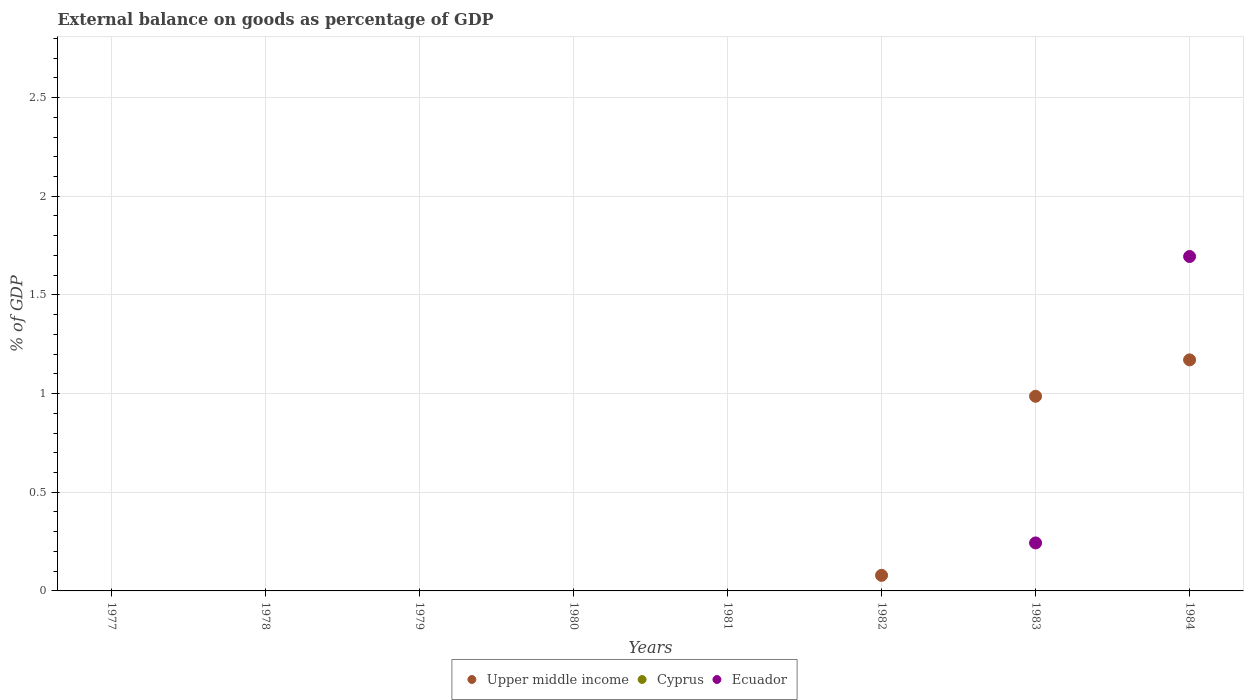Is the number of dotlines equal to the number of legend labels?
Make the answer very short. No. Across all years, what is the maximum external balance on goods as percentage of GDP in Ecuador?
Offer a terse response. 1.69. Across all years, what is the minimum external balance on goods as percentage of GDP in Upper middle income?
Make the answer very short. 0. What is the total external balance on goods as percentage of GDP in Ecuador in the graph?
Provide a short and direct response. 1.94. What is the difference between the external balance on goods as percentage of GDP in Cyprus in 1978 and the external balance on goods as percentage of GDP in Upper middle income in 1980?
Provide a short and direct response. 0. What is the average external balance on goods as percentage of GDP in Ecuador per year?
Your answer should be compact. 0.24. What is the difference between the highest and the second highest external balance on goods as percentage of GDP in Upper middle income?
Give a very brief answer. 0.18. What is the difference between the highest and the lowest external balance on goods as percentage of GDP in Upper middle income?
Give a very brief answer. 1.17. In how many years, is the external balance on goods as percentage of GDP in Cyprus greater than the average external balance on goods as percentage of GDP in Cyprus taken over all years?
Your response must be concise. 0. Is it the case that in every year, the sum of the external balance on goods as percentage of GDP in Ecuador and external balance on goods as percentage of GDP in Upper middle income  is greater than the external balance on goods as percentage of GDP in Cyprus?
Your answer should be compact. No. Is the external balance on goods as percentage of GDP in Ecuador strictly greater than the external balance on goods as percentage of GDP in Cyprus over the years?
Ensure brevity in your answer.  Yes. Is the external balance on goods as percentage of GDP in Ecuador strictly less than the external balance on goods as percentage of GDP in Upper middle income over the years?
Provide a succinct answer. No. How many dotlines are there?
Offer a terse response. 2. Does the graph contain any zero values?
Offer a very short reply. Yes. Does the graph contain grids?
Keep it short and to the point. Yes. Where does the legend appear in the graph?
Ensure brevity in your answer.  Bottom center. How many legend labels are there?
Your response must be concise. 3. What is the title of the graph?
Give a very brief answer. External balance on goods as percentage of GDP. What is the label or title of the X-axis?
Ensure brevity in your answer.  Years. What is the label or title of the Y-axis?
Offer a very short reply. % of GDP. What is the % of GDP of Upper middle income in 1977?
Make the answer very short. 0. What is the % of GDP of Cyprus in 1978?
Your answer should be compact. 0. What is the % of GDP in Upper middle income in 1979?
Keep it short and to the point. 0. What is the % of GDP of Cyprus in 1979?
Give a very brief answer. 0. What is the % of GDP in Upper middle income in 1981?
Ensure brevity in your answer.  0. What is the % of GDP of Cyprus in 1981?
Your answer should be very brief. 0. What is the % of GDP of Upper middle income in 1982?
Make the answer very short. 0.08. What is the % of GDP of Upper middle income in 1983?
Offer a terse response. 0.99. What is the % of GDP of Cyprus in 1983?
Provide a short and direct response. 0. What is the % of GDP in Ecuador in 1983?
Your response must be concise. 0.24. What is the % of GDP of Upper middle income in 1984?
Your answer should be compact. 1.17. What is the % of GDP in Cyprus in 1984?
Keep it short and to the point. 0. What is the % of GDP of Ecuador in 1984?
Ensure brevity in your answer.  1.69. Across all years, what is the maximum % of GDP in Upper middle income?
Provide a succinct answer. 1.17. Across all years, what is the maximum % of GDP in Ecuador?
Your answer should be very brief. 1.69. Across all years, what is the minimum % of GDP in Upper middle income?
Give a very brief answer. 0. What is the total % of GDP of Upper middle income in the graph?
Make the answer very short. 2.24. What is the total % of GDP in Cyprus in the graph?
Provide a short and direct response. 0. What is the total % of GDP in Ecuador in the graph?
Provide a succinct answer. 1.94. What is the difference between the % of GDP in Upper middle income in 1982 and that in 1983?
Give a very brief answer. -0.91. What is the difference between the % of GDP in Upper middle income in 1982 and that in 1984?
Your answer should be compact. -1.09. What is the difference between the % of GDP of Upper middle income in 1983 and that in 1984?
Make the answer very short. -0.18. What is the difference between the % of GDP in Ecuador in 1983 and that in 1984?
Provide a short and direct response. -1.45. What is the difference between the % of GDP in Upper middle income in 1982 and the % of GDP in Ecuador in 1983?
Give a very brief answer. -0.16. What is the difference between the % of GDP of Upper middle income in 1982 and the % of GDP of Ecuador in 1984?
Keep it short and to the point. -1.62. What is the difference between the % of GDP of Upper middle income in 1983 and the % of GDP of Ecuador in 1984?
Your answer should be compact. -0.71. What is the average % of GDP in Upper middle income per year?
Provide a succinct answer. 0.28. What is the average % of GDP of Ecuador per year?
Make the answer very short. 0.24. In the year 1983, what is the difference between the % of GDP in Upper middle income and % of GDP in Ecuador?
Offer a very short reply. 0.74. In the year 1984, what is the difference between the % of GDP of Upper middle income and % of GDP of Ecuador?
Provide a short and direct response. -0.52. What is the ratio of the % of GDP of Upper middle income in 1982 to that in 1983?
Offer a very short reply. 0.08. What is the ratio of the % of GDP of Upper middle income in 1982 to that in 1984?
Your answer should be compact. 0.07. What is the ratio of the % of GDP of Upper middle income in 1983 to that in 1984?
Your answer should be very brief. 0.84. What is the ratio of the % of GDP in Ecuador in 1983 to that in 1984?
Make the answer very short. 0.14. What is the difference between the highest and the second highest % of GDP of Upper middle income?
Ensure brevity in your answer.  0.18. What is the difference between the highest and the lowest % of GDP of Upper middle income?
Provide a short and direct response. 1.17. What is the difference between the highest and the lowest % of GDP of Ecuador?
Make the answer very short. 1.69. 